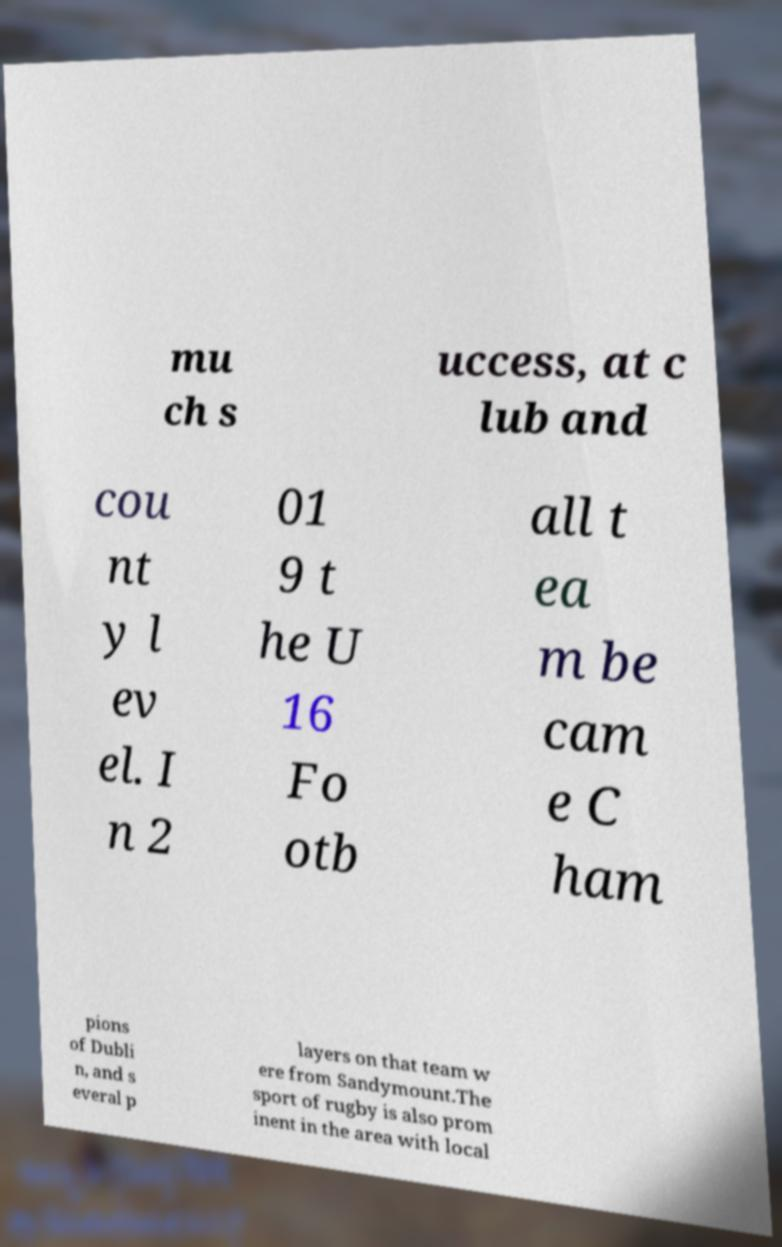Please read and relay the text visible in this image. What does it say? mu ch s uccess, at c lub and cou nt y l ev el. I n 2 01 9 t he U 16 Fo otb all t ea m be cam e C ham pions of Dubli n, and s everal p layers on that team w ere from Sandymount.The sport of rugby is also prom inent in the area with local 